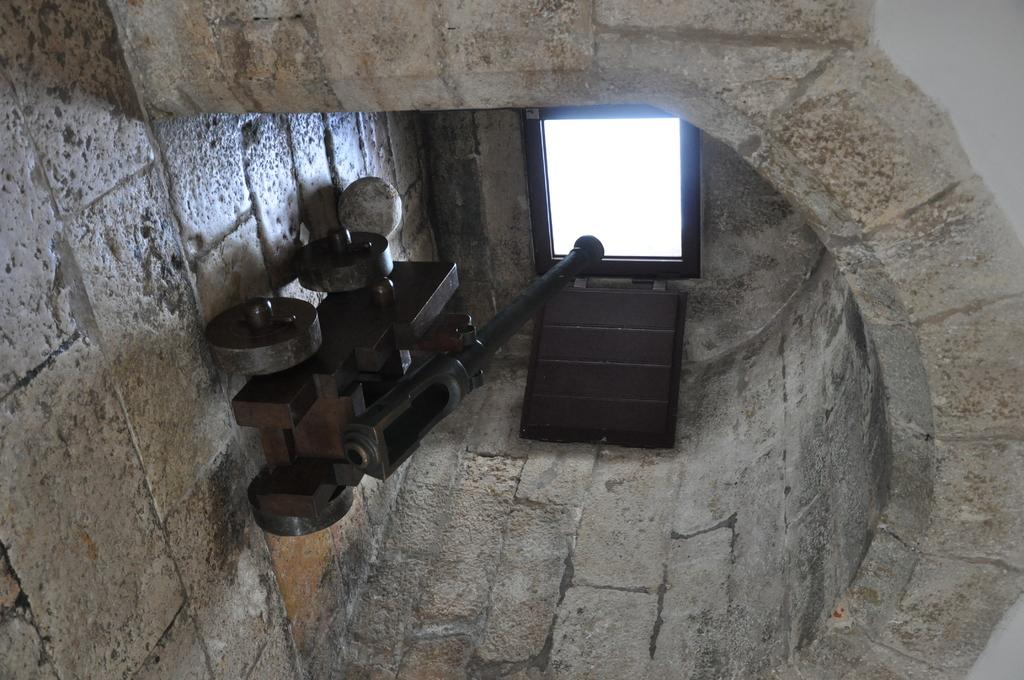What is the main object in the image? There is a cannon in the image. What is on the floor near the cannon? There is a ball on the floor in the image. Where are the cannon and ball located? The cannon and ball are under a curved roof. What architectural feature can be seen in the image? There is a window in the middle of a wall in the image. What type of silk fabric is draped over the cannon in the image? There is no silk fabric present in the image; the cannon is not covered by any fabric. 